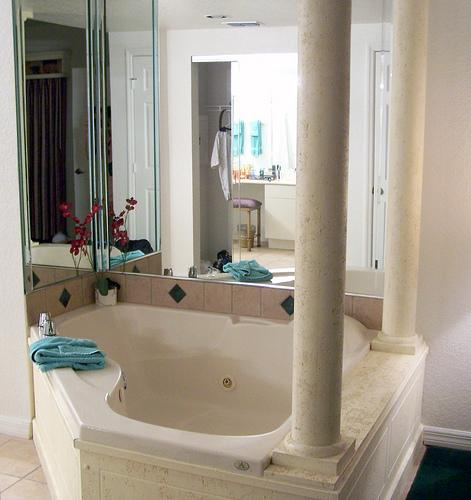What is the purpose of the round objects in the tub? six 